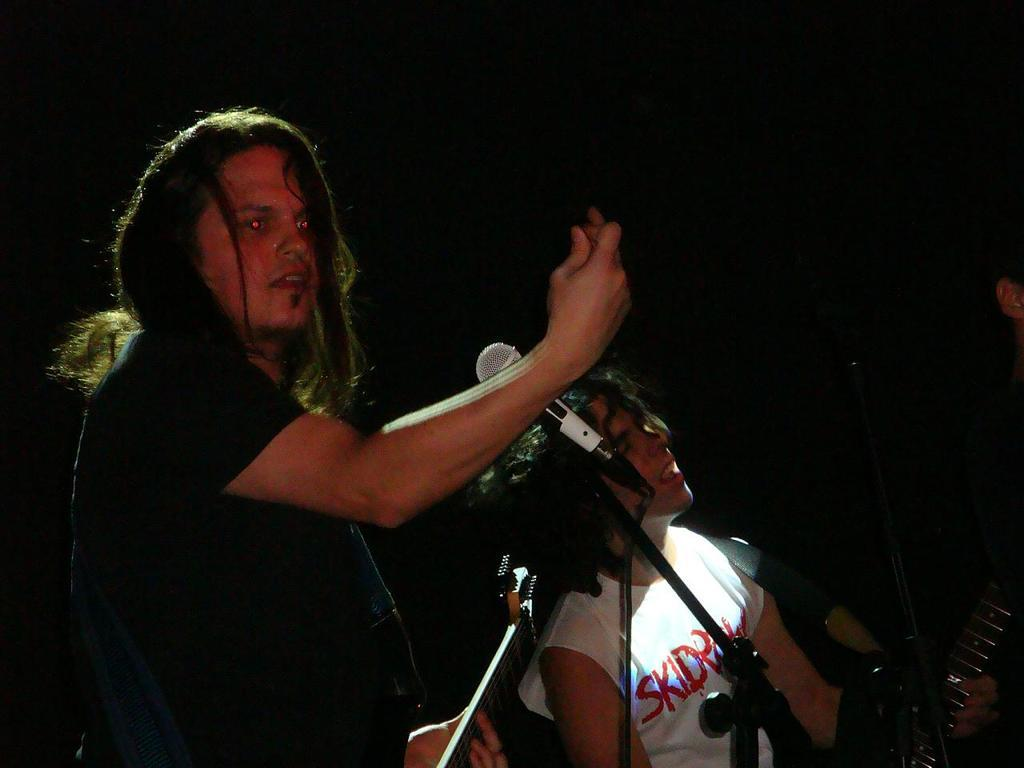How many people are in the image? There are two persons in the image. What are the persons doing in the image? The persons are holding musical instruments. Can you describe any equipment related to sound in the image? Yes, there is a microphone with a rod and wire in the image. What is the color of the background in the image? The background of the image is dark. What type of stocking is being used to play chess in the image? There is no stocking or chess game present in the image. 